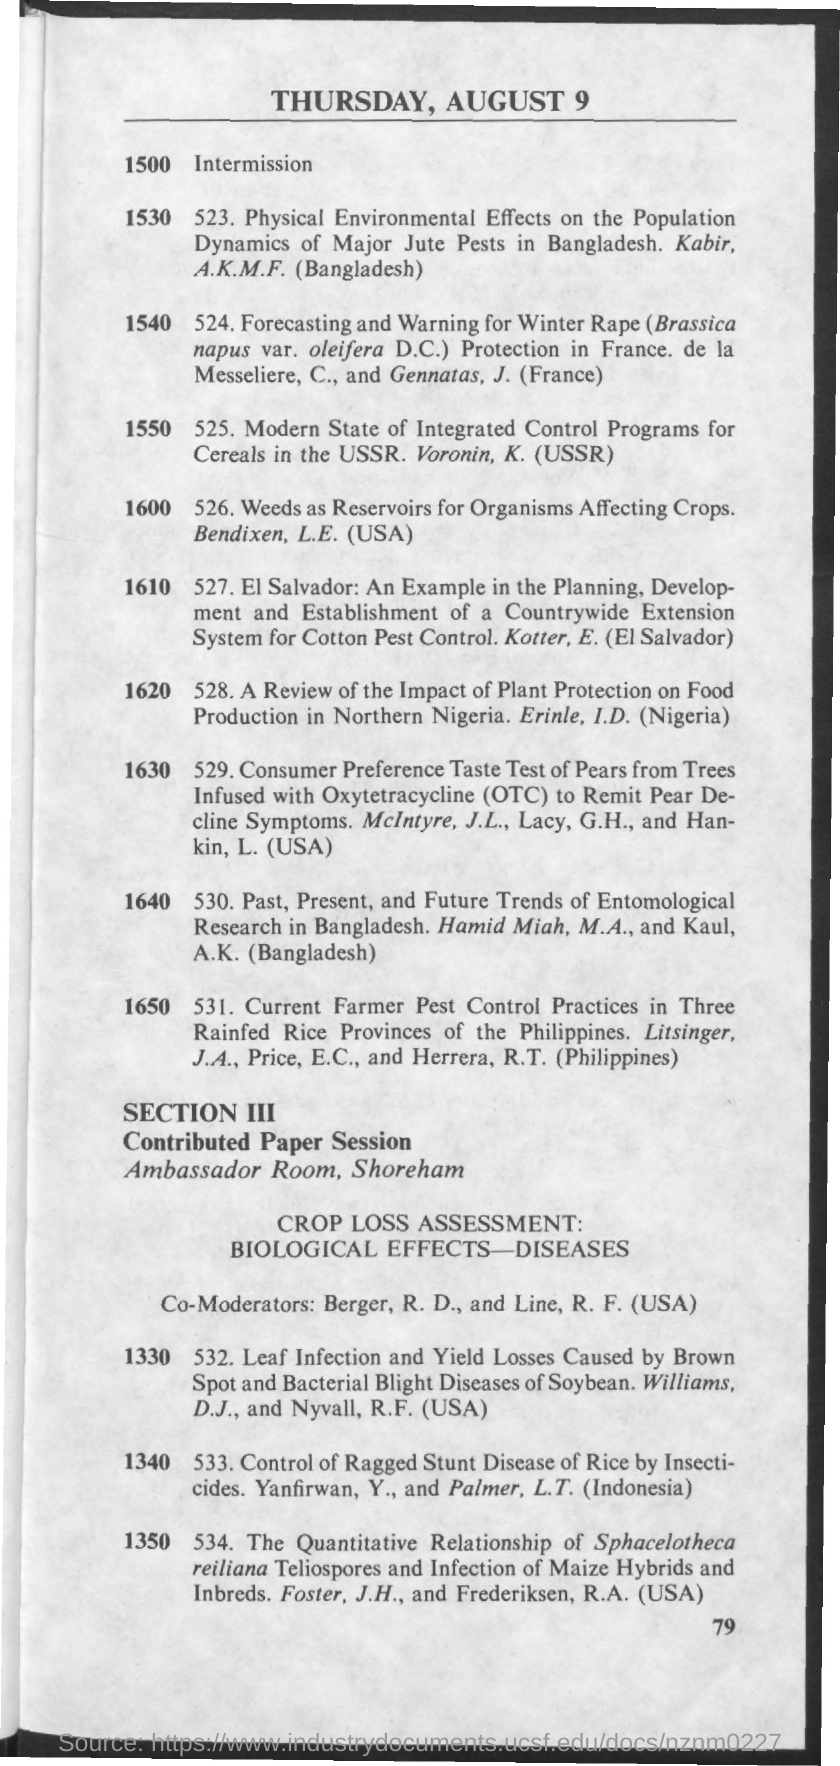What is the date mentioned in the document at the top?
Provide a short and direct response. Thursday,August 9. What is the Page Number?
Your answer should be very brief. 79. Who all are the co-moderators?
Your answer should be very brief. Berger,R. D., and Line, R.F. 